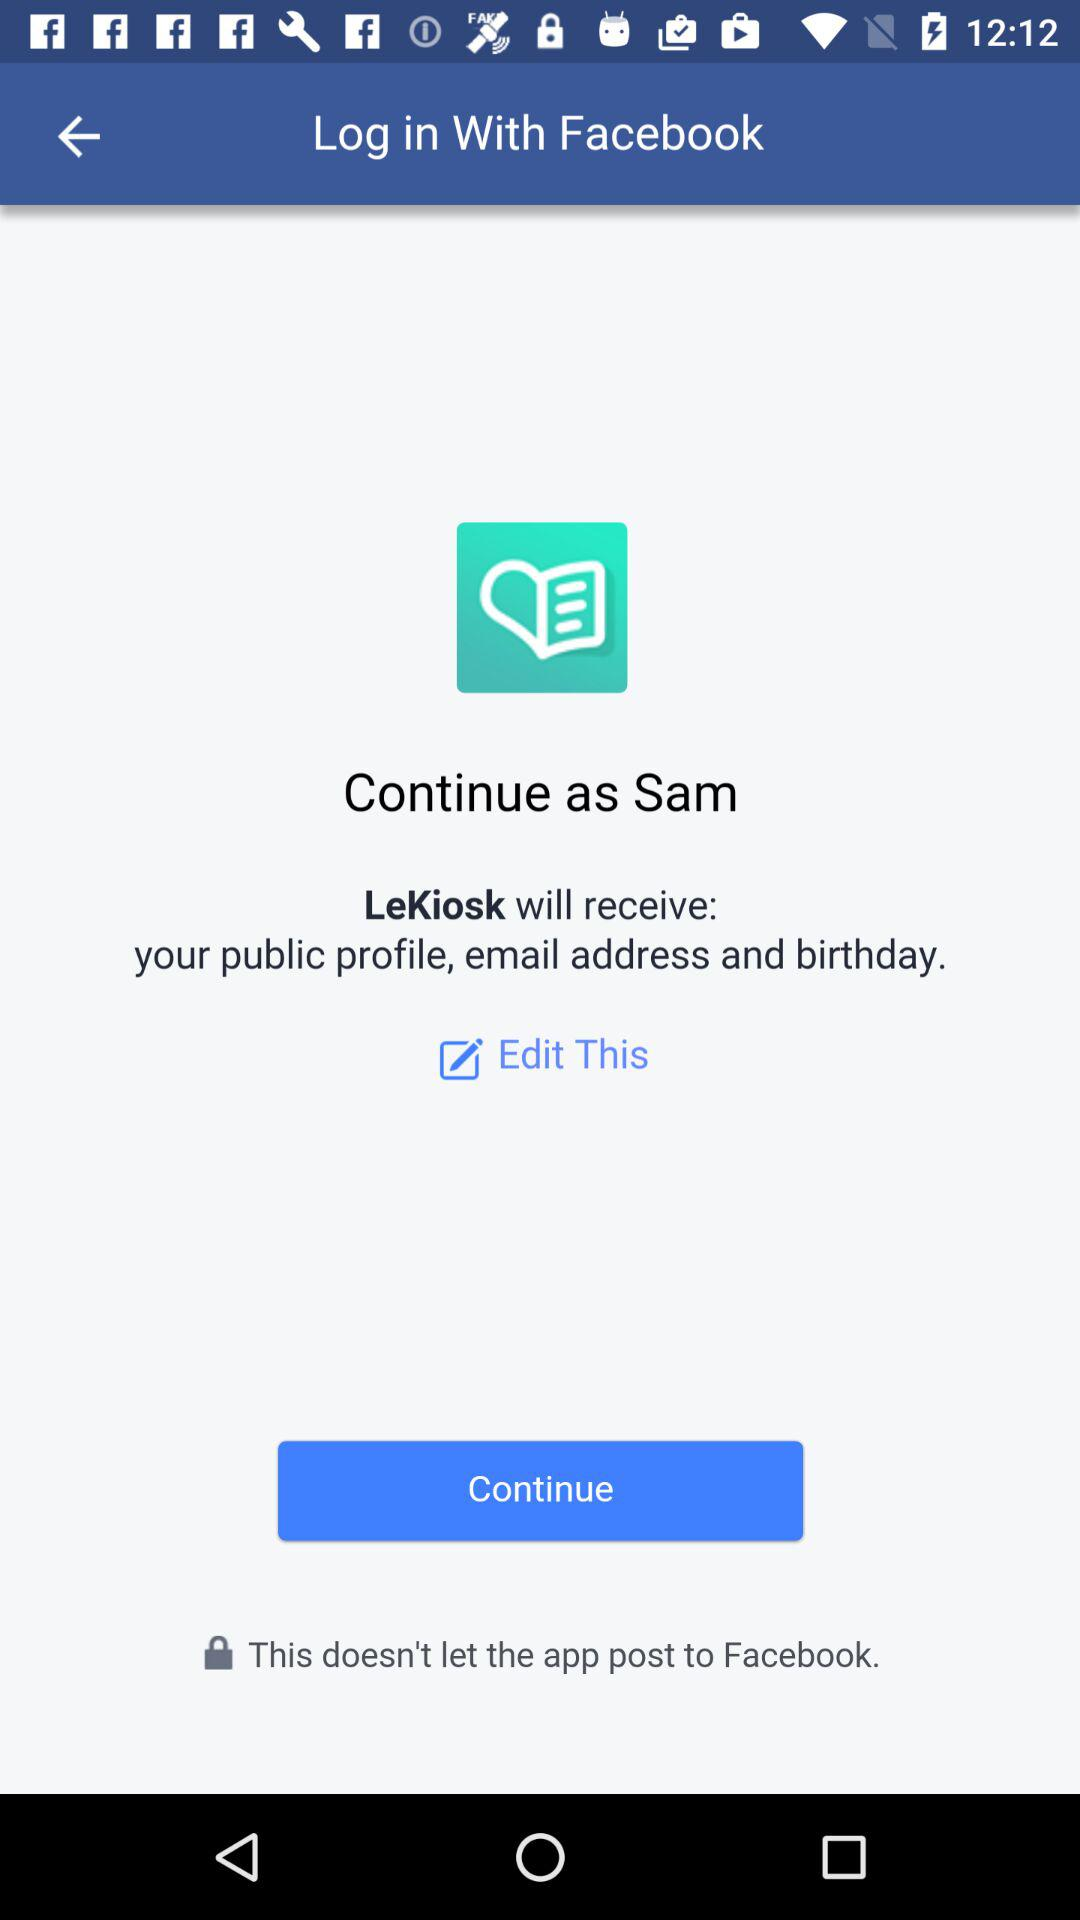What application will receive a public profile, email address and birthday? The application is "LeKiosk". 